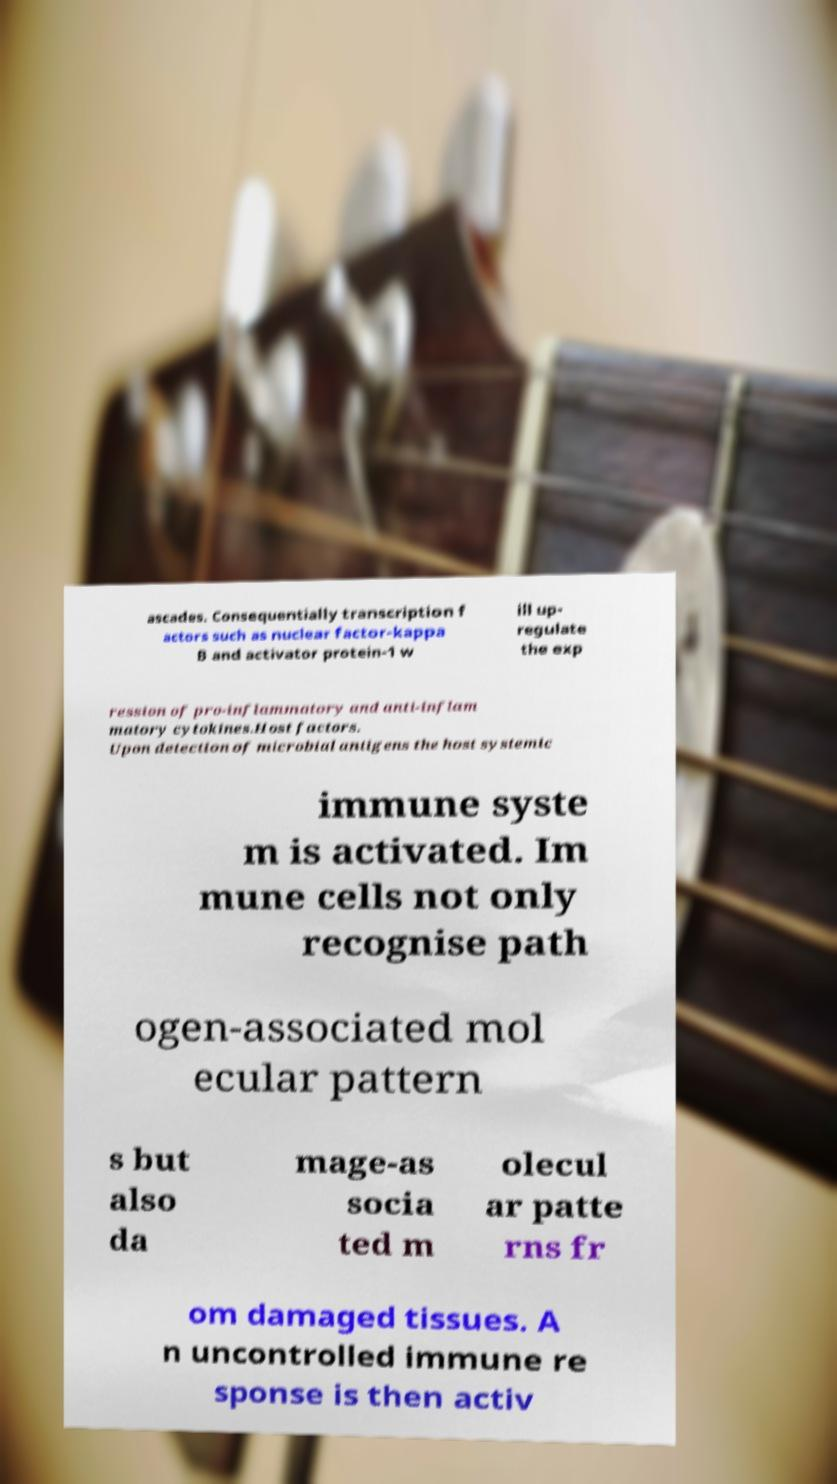Could you extract and type out the text from this image? ascades. Consequentially transcription f actors such as nuclear factor-kappa B and activator protein-1 w ill up- regulate the exp ression of pro-inflammatory and anti-inflam matory cytokines.Host factors. Upon detection of microbial antigens the host systemic immune syste m is activated. Im mune cells not only recognise path ogen-associated mol ecular pattern s but also da mage-as socia ted m olecul ar patte rns fr om damaged tissues. A n uncontrolled immune re sponse is then activ 